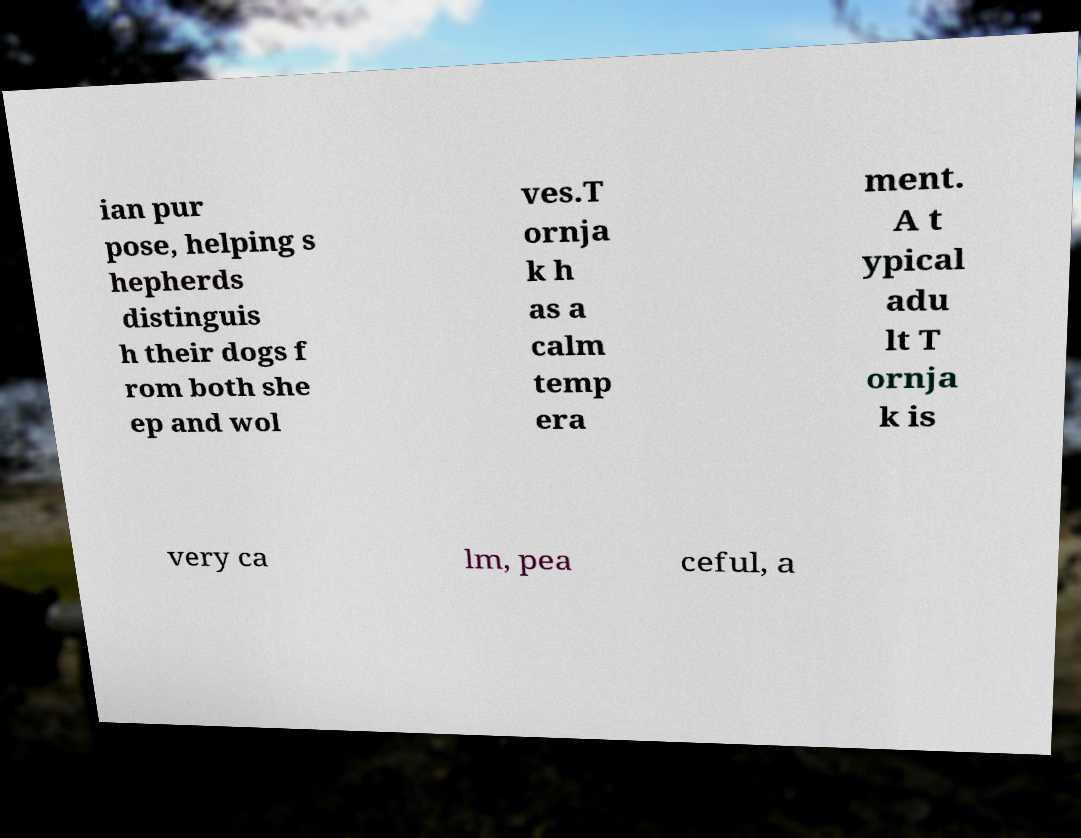Please identify and transcribe the text found in this image. ian pur pose, helping s hepherds distinguis h their dogs f rom both she ep and wol ves.T ornja k h as a calm temp era ment. A t ypical adu lt T ornja k is very ca lm, pea ceful, a 